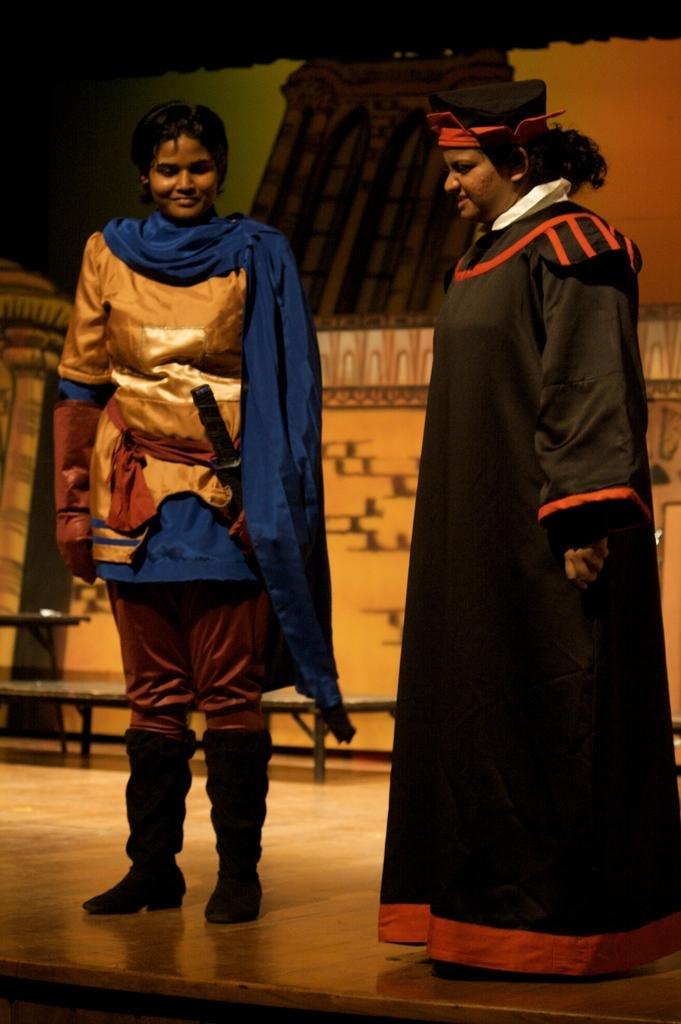What is happening in the center of the image? There are persons standing in the center of the image. What can be seen in the background of the image? There is a stage and a bench in the background of the image. Can you describe the person on the left side in the front? The person on the left side in the front is standing and smiling. What type of tent is visible in the background of the image? There is no tent present in the background; it features persons standing in the center, a stage, and a bench in the background. 